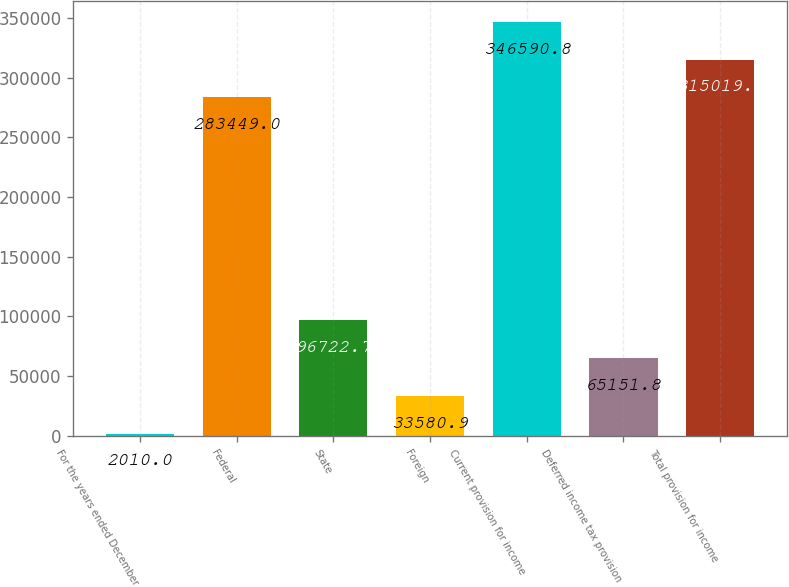<chart> <loc_0><loc_0><loc_500><loc_500><bar_chart><fcel>For the years ended December<fcel>Federal<fcel>State<fcel>Foreign<fcel>Current provision for income<fcel>Deferred income tax provision<fcel>Total provision for income<nl><fcel>2010<fcel>283449<fcel>96722.7<fcel>33580.9<fcel>346591<fcel>65151.8<fcel>315020<nl></chart> 